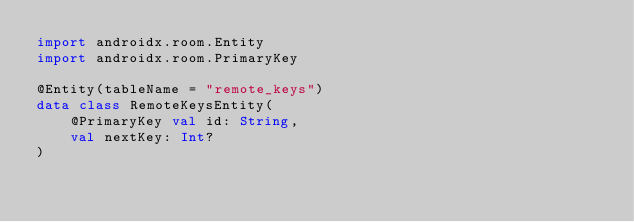<code> <loc_0><loc_0><loc_500><loc_500><_Kotlin_>import androidx.room.Entity
import androidx.room.PrimaryKey

@Entity(tableName = "remote_keys")
data class RemoteKeysEntity(
    @PrimaryKey val id: String,
    val nextKey: Int?
)
</code> 